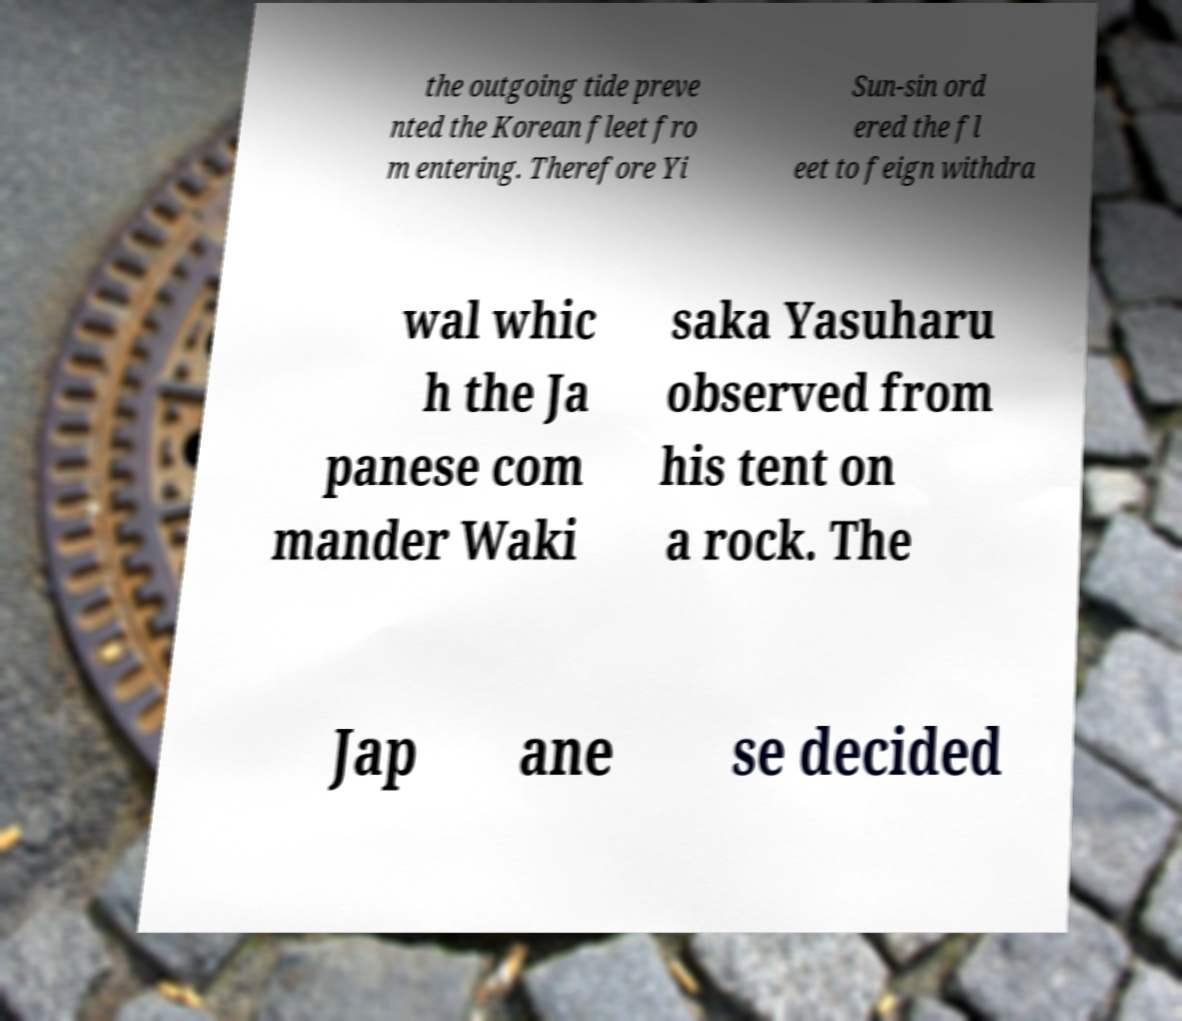Please identify and transcribe the text found in this image. the outgoing tide preve nted the Korean fleet fro m entering. Therefore Yi Sun-sin ord ered the fl eet to feign withdra wal whic h the Ja panese com mander Waki saka Yasuharu observed from his tent on a rock. The Jap ane se decided 